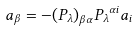Convert formula to latex. <formula><loc_0><loc_0><loc_500><loc_500>a _ { \beta } = - { ( P _ { \lambda } ) } _ { \beta \alpha } { P _ { \lambda } } ^ { \alpha i } a _ { i }</formula> 